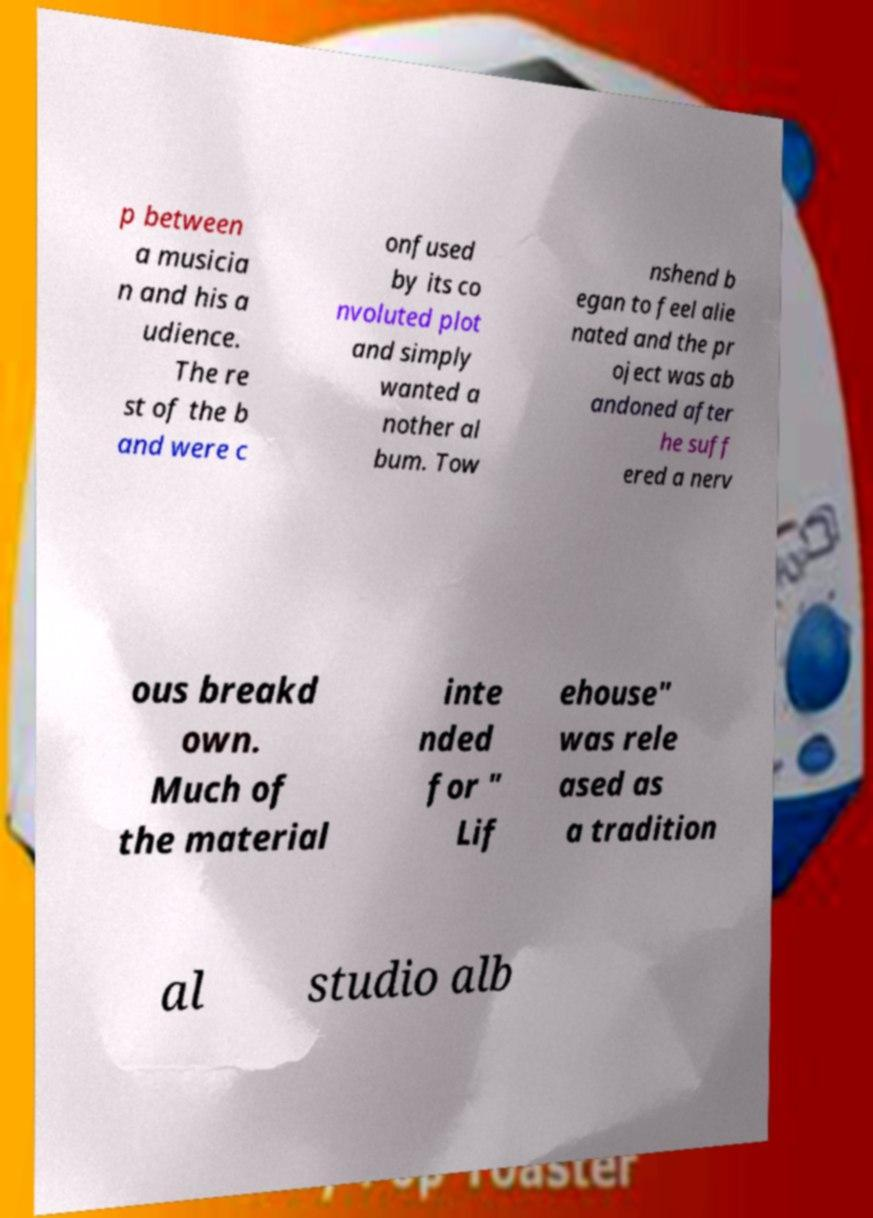What messages or text are displayed in this image? I need them in a readable, typed format. p between a musicia n and his a udience. The re st of the b and were c onfused by its co nvoluted plot and simply wanted a nother al bum. Tow nshend b egan to feel alie nated and the pr oject was ab andoned after he suff ered a nerv ous breakd own. Much of the material inte nded for " Lif ehouse" was rele ased as a tradition al studio alb 